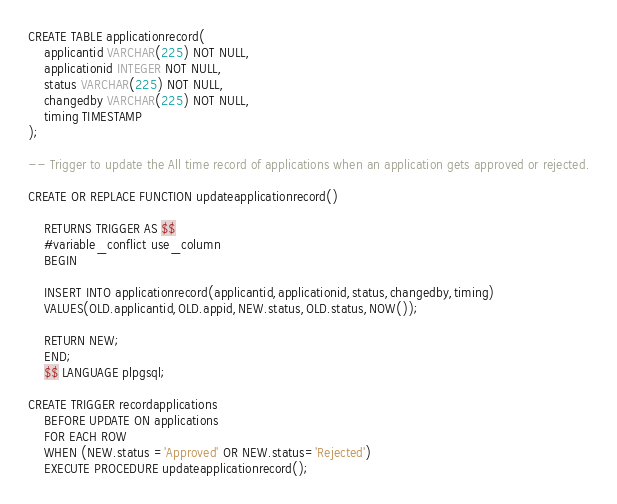<code> <loc_0><loc_0><loc_500><loc_500><_SQL_>CREATE TABLE applicationrecord(
	applicantid VARCHAR(225) NOT NULL,
	applicationid INTEGER NOT NULL,
	status VARCHAR(225) NOT NULL,
	changedby VARCHAR(225) NOT NULL,
	timing TIMESTAMP
);

-- Trigger to update the All time record of applications when an application gets approved or rejected.

CREATE OR REPLACE FUNCTION updateapplicationrecord()

	RETURNS TRIGGER AS $$
	#variable_conflict use_column
	BEGIN
	
	INSERT INTO applicationrecord(applicantid,applicationid,status,changedby,timing)
	VALUES(OLD.applicantid,OLD.appid,NEW.status,OLD.status,NOW());
	
	RETURN NEW;
	END;
	$$ LANGUAGE plpgsql;

CREATE TRIGGER recordapplications
	BEFORE UPDATE ON applications
	FOR EACH ROW
	WHEN (NEW.status ='Approved' OR NEW.status='Rejected')
	EXECUTE PROCEDURE updateapplicationrecord();

</code> 